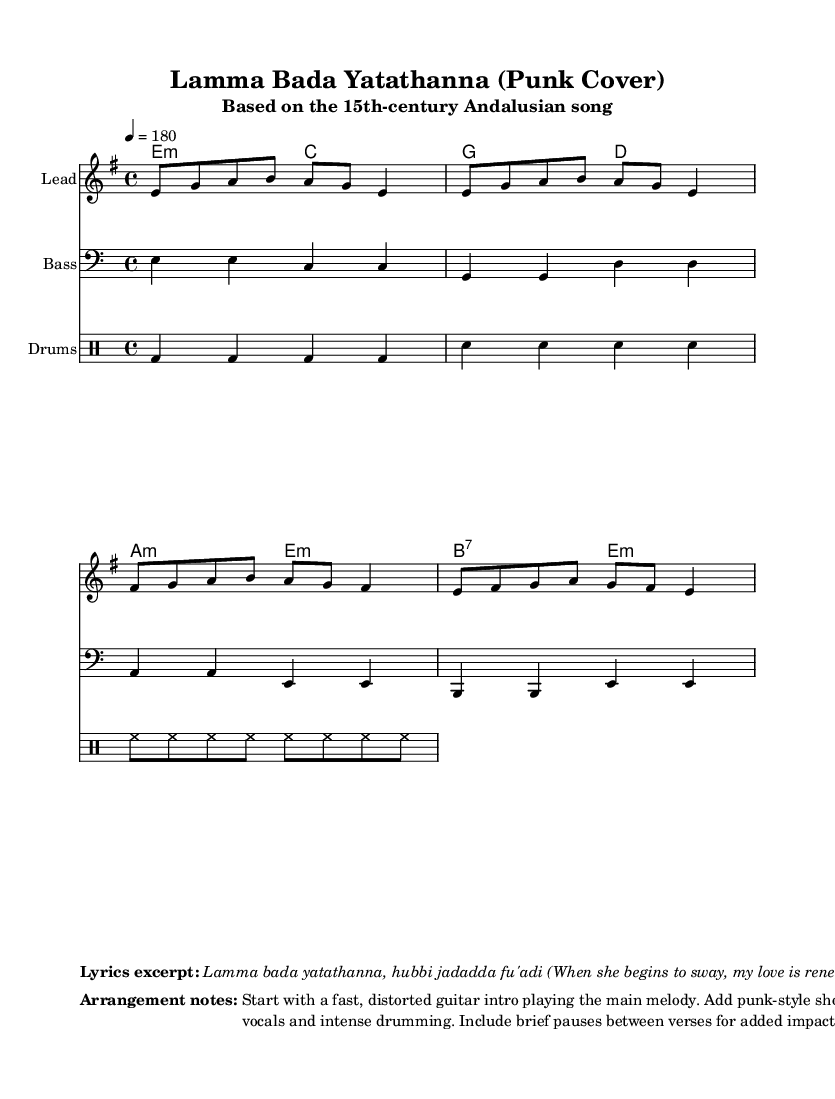What is the key signature of this music? The key signature is E minor, which has one sharp (F#). This can be identified in the sheet music where the number of sharps in the key signature is indicated.
Answer: E minor What is the time signature of this music? The time signature is 4/4, which indicates that there are four beats in each measure and the quarter note gets the beat. This is shown at the beginning of the sheet music.
Answer: 4/4 What is the tempo marking of this music? The tempo marking is 180 beats per minute, which is indicated by the tempo directive "4 = 180" found in the global settings of the sheet music.
Answer: 180 How many measures are in the melody section? The melody section consists of four measures, as indicated by the repeated patterns of notes. Counting the measures gives us the total.
Answer: 4 measures What instrumental role does the bass play in this arrangement? The bass plays a supportive rhythmic and harmonic role, providing the foundation for the rest of the instruments to build upon, which can be inferred from its rhythmic patterns and note choices.
Answer: Supportive What style of vocals is indicated in the arrangement notes? The arrangement notes mention "punk-style shouted vocals," which refers to the energetic and aggressive style characteristic of punk music. This is specifically mentioned in the arrangement notes section.
Answer: Shouted What historical context is this song based on? The song is based on a 15th-century Andalusian folk song, which provides cultural depth and historical significance to the music. This is stated explicitly in the subtitle of the sheet music.
Answer: 15th-century Andalusian 